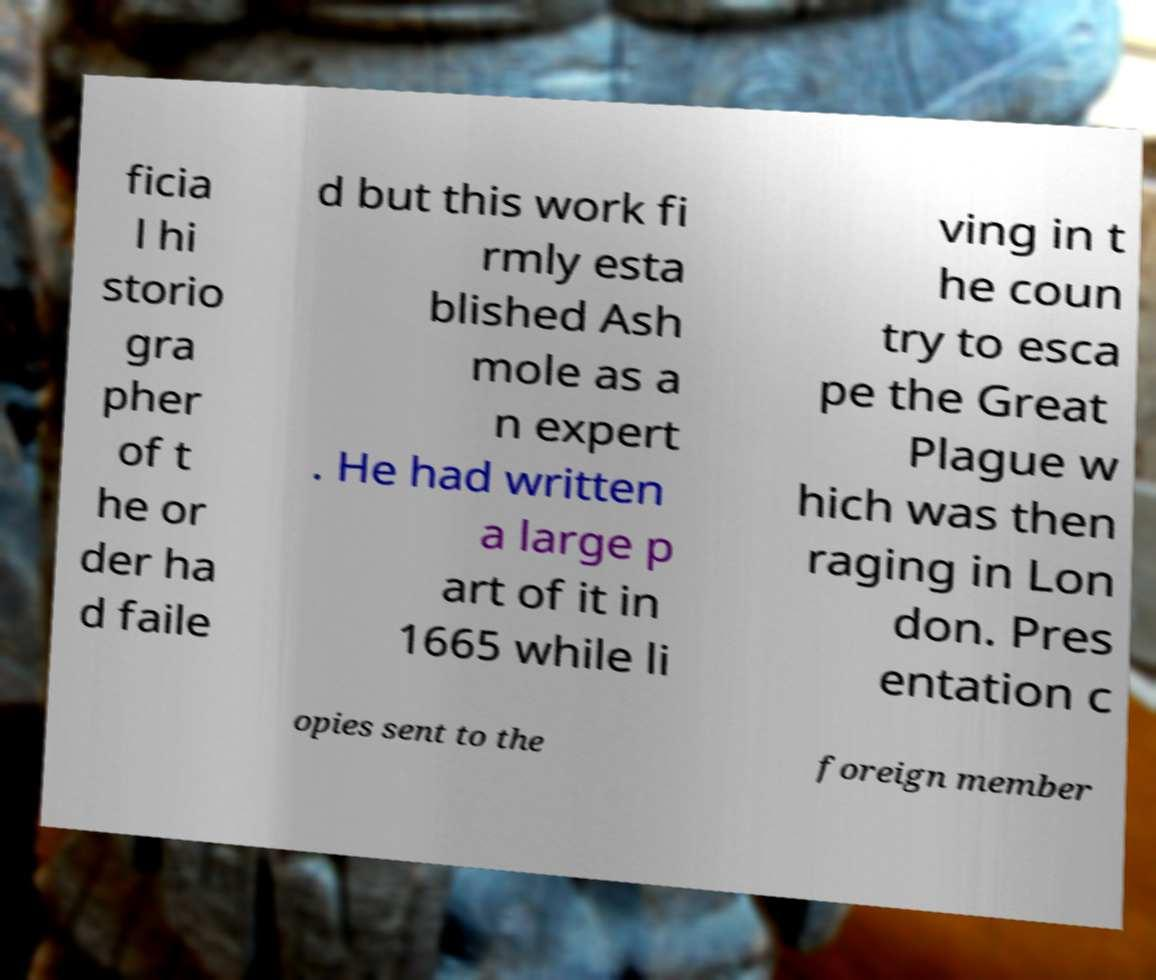Could you extract and type out the text from this image? ficia l hi storio gra pher of t he or der ha d faile d but this work fi rmly esta blished Ash mole as a n expert . He had written a large p art of it in 1665 while li ving in t he coun try to esca pe the Great Plague w hich was then raging in Lon don. Pres entation c opies sent to the foreign member 